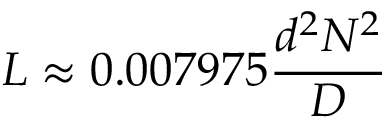Convert formula to latex. <formula><loc_0><loc_0><loc_500><loc_500>L \approx 0 . 0 0 7 9 7 5 { \frac { d ^ { 2 } N ^ { 2 } } { D } }</formula> 